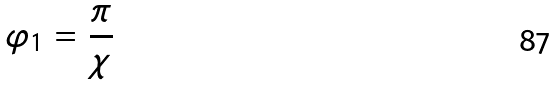Convert formula to latex. <formula><loc_0><loc_0><loc_500><loc_500>\varphi _ { 1 } = \frac { \pi } { \chi }</formula> 